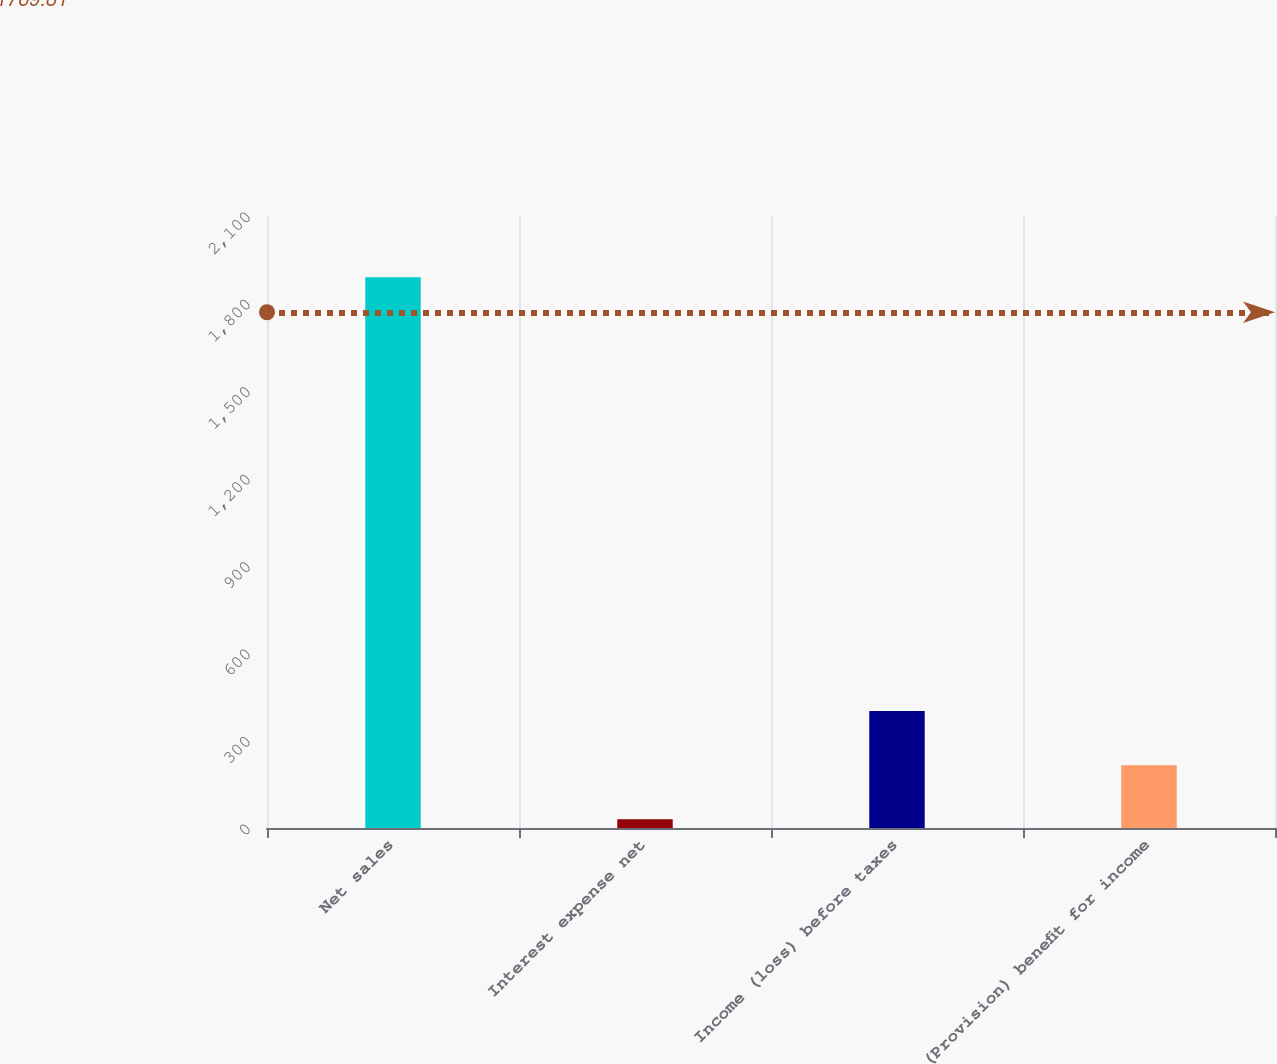Convert chart. <chart><loc_0><loc_0><loc_500><loc_500><bar_chart><fcel>Net sales<fcel>Interest expense net<fcel>Income (loss) before taxes<fcel>(Provision) benefit for income<nl><fcel>1890.1<fcel>29.6<fcel>401.7<fcel>215.65<nl></chart> 